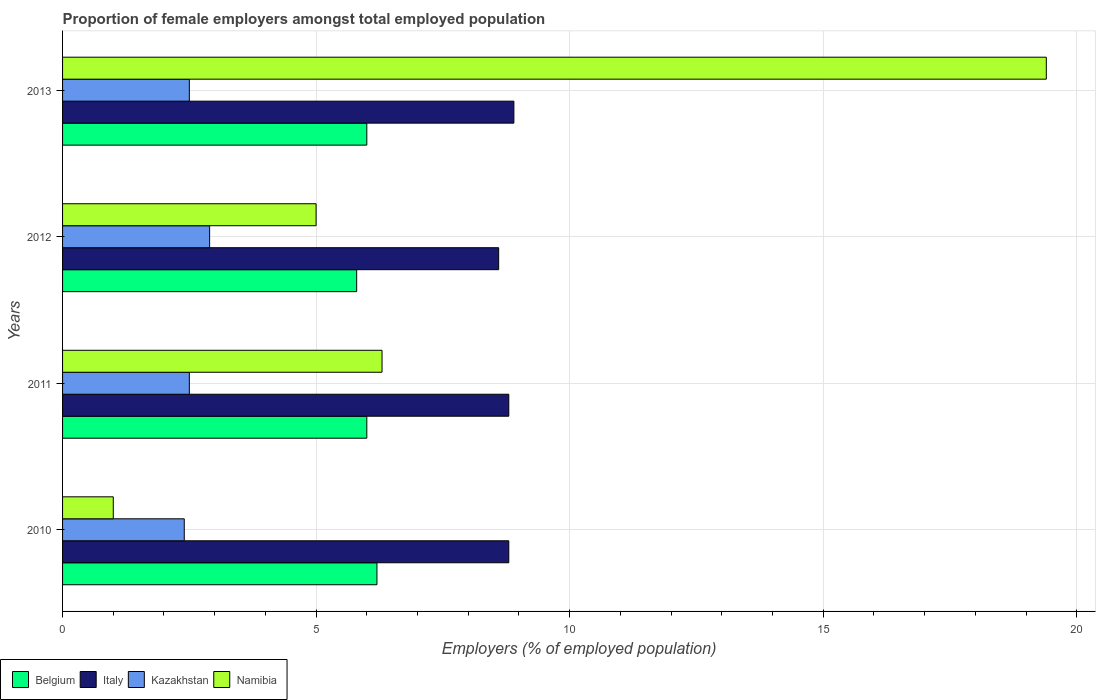Are the number of bars per tick equal to the number of legend labels?
Your response must be concise. Yes. Are the number of bars on each tick of the Y-axis equal?
Offer a terse response. Yes. How many bars are there on the 1st tick from the top?
Provide a short and direct response. 4. How many bars are there on the 2nd tick from the bottom?
Keep it short and to the point. 4. What is the label of the 2nd group of bars from the top?
Provide a succinct answer. 2012. In how many cases, is the number of bars for a given year not equal to the number of legend labels?
Your answer should be very brief. 0. What is the proportion of female employers in Kazakhstan in 2012?
Ensure brevity in your answer.  2.9. Across all years, what is the maximum proportion of female employers in Italy?
Keep it short and to the point. 8.9. Across all years, what is the minimum proportion of female employers in Italy?
Offer a terse response. 8.6. In which year was the proportion of female employers in Belgium maximum?
Offer a terse response. 2010. What is the total proportion of female employers in Kazakhstan in the graph?
Make the answer very short. 10.3. What is the difference between the proportion of female employers in Italy in 2011 and the proportion of female employers in Belgium in 2013?
Give a very brief answer. 2.8. In the year 2013, what is the difference between the proportion of female employers in Kazakhstan and proportion of female employers in Belgium?
Offer a very short reply. -3.5. In how many years, is the proportion of female employers in Kazakhstan greater than 19 %?
Your answer should be very brief. 0. What is the ratio of the proportion of female employers in Namibia in 2012 to that in 2013?
Provide a succinct answer. 0.26. What is the difference between the highest and the second highest proportion of female employers in Kazakhstan?
Give a very brief answer. 0.4. What is the difference between the highest and the lowest proportion of female employers in Namibia?
Make the answer very short. 18.4. In how many years, is the proportion of female employers in Italy greater than the average proportion of female employers in Italy taken over all years?
Keep it short and to the point. 3. Is it the case that in every year, the sum of the proportion of female employers in Belgium and proportion of female employers in Kazakhstan is greater than the sum of proportion of female employers in Italy and proportion of female employers in Namibia?
Ensure brevity in your answer.  No. What does the 4th bar from the bottom in 2012 represents?
Keep it short and to the point. Namibia. How many bars are there?
Offer a very short reply. 16. Are all the bars in the graph horizontal?
Provide a short and direct response. Yes. How many years are there in the graph?
Provide a succinct answer. 4. What is the difference between two consecutive major ticks on the X-axis?
Provide a succinct answer. 5. Are the values on the major ticks of X-axis written in scientific E-notation?
Offer a terse response. No. Does the graph contain any zero values?
Provide a short and direct response. No. Does the graph contain grids?
Make the answer very short. Yes. Where does the legend appear in the graph?
Provide a succinct answer. Bottom left. How are the legend labels stacked?
Your response must be concise. Horizontal. What is the title of the graph?
Make the answer very short. Proportion of female employers amongst total employed population. Does "Middle East & North Africa (developing only)" appear as one of the legend labels in the graph?
Provide a short and direct response. No. What is the label or title of the X-axis?
Provide a succinct answer. Employers (% of employed population). What is the label or title of the Y-axis?
Offer a terse response. Years. What is the Employers (% of employed population) in Belgium in 2010?
Your answer should be compact. 6.2. What is the Employers (% of employed population) of Italy in 2010?
Your response must be concise. 8.8. What is the Employers (% of employed population) in Kazakhstan in 2010?
Your answer should be compact. 2.4. What is the Employers (% of employed population) of Italy in 2011?
Ensure brevity in your answer.  8.8. What is the Employers (% of employed population) of Kazakhstan in 2011?
Offer a terse response. 2.5. What is the Employers (% of employed population) of Namibia in 2011?
Make the answer very short. 6.3. What is the Employers (% of employed population) of Belgium in 2012?
Offer a terse response. 5.8. What is the Employers (% of employed population) in Italy in 2012?
Offer a very short reply. 8.6. What is the Employers (% of employed population) in Kazakhstan in 2012?
Offer a terse response. 2.9. What is the Employers (% of employed population) of Belgium in 2013?
Your answer should be compact. 6. What is the Employers (% of employed population) of Italy in 2013?
Provide a short and direct response. 8.9. What is the Employers (% of employed population) in Namibia in 2013?
Offer a very short reply. 19.4. Across all years, what is the maximum Employers (% of employed population) in Belgium?
Make the answer very short. 6.2. Across all years, what is the maximum Employers (% of employed population) in Italy?
Your response must be concise. 8.9. Across all years, what is the maximum Employers (% of employed population) of Kazakhstan?
Your answer should be compact. 2.9. Across all years, what is the maximum Employers (% of employed population) in Namibia?
Provide a short and direct response. 19.4. Across all years, what is the minimum Employers (% of employed population) of Belgium?
Offer a terse response. 5.8. Across all years, what is the minimum Employers (% of employed population) in Italy?
Offer a terse response. 8.6. Across all years, what is the minimum Employers (% of employed population) of Kazakhstan?
Make the answer very short. 2.4. Across all years, what is the minimum Employers (% of employed population) of Namibia?
Provide a succinct answer. 1. What is the total Employers (% of employed population) of Italy in the graph?
Make the answer very short. 35.1. What is the total Employers (% of employed population) in Kazakhstan in the graph?
Make the answer very short. 10.3. What is the total Employers (% of employed population) of Namibia in the graph?
Your response must be concise. 31.7. What is the difference between the Employers (% of employed population) in Belgium in 2010 and that in 2011?
Provide a short and direct response. 0.2. What is the difference between the Employers (% of employed population) in Namibia in 2010 and that in 2011?
Make the answer very short. -5.3. What is the difference between the Employers (% of employed population) in Belgium in 2010 and that in 2012?
Ensure brevity in your answer.  0.4. What is the difference between the Employers (% of employed population) in Italy in 2010 and that in 2012?
Keep it short and to the point. 0.2. What is the difference between the Employers (% of employed population) of Kazakhstan in 2010 and that in 2012?
Make the answer very short. -0.5. What is the difference between the Employers (% of employed population) of Italy in 2010 and that in 2013?
Provide a short and direct response. -0.1. What is the difference between the Employers (% of employed population) of Kazakhstan in 2010 and that in 2013?
Offer a terse response. -0.1. What is the difference between the Employers (% of employed population) of Namibia in 2010 and that in 2013?
Provide a succinct answer. -18.4. What is the difference between the Employers (% of employed population) in Belgium in 2011 and that in 2012?
Your answer should be very brief. 0.2. What is the difference between the Employers (% of employed population) in Italy in 2011 and that in 2012?
Provide a succinct answer. 0.2. What is the difference between the Employers (% of employed population) in Kazakhstan in 2011 and that in 2012?
Give a very brief answer. -0.4. What is the difference between the Employers (% of employed population) in Namibia in 2011 and that in 2012?
Offer a very short reply. 1.3. What is the difference between the Employers (% of employed population) of Belgium in 2011 and that in 2013?
Provide a succinct answer. 0. What is the difference between the Employers (% of employed population) of Italy in 2011 and that in 2013?
Your answer should be compact. -0.1. What is the difference between the Employers (% of employed population) in Kazakhstan in 2011 and that in 2013?
Offer a very short reply. 0. What is the difference between the Employers (% of employed population) of Namibia in 2011 and that in 2013?
Offer a terse response. -13.1. What is the difference between the Employers (% of employed population) of Kazakhstan in 2012 and that in 2013?
Your answer should be very brief. 0.4. What is the difference between the Employers (% of employed population) of Namibia in 2012 and that in 2013?
Keep it short and to the point. -14.4. What is the difference between the Employers (% of employed population) of Belgium in 2010 and the Employers (% of employed population) of Italy in 2011?
Your response must be concise. -2.6. What is the difference between the Employers (% of employed population) in Italy in 2010 and the Employers (% of employed population) in Namibia in 2011?
Your answer should be very brief. 2.5. What is the difference between the Employers (% of employed population) of Kazakhstan in 2010 and the Employers (% of employed population) of Namibia in 2011?
Keep it short and to the point. -3.9. What is the difference between the Employers (% of employed population) in Belgium in 2010 and the Employers (% of employed population) in Italy in 2012?
Your answer should be very brief. -2.4. What is the difference between the Employers (% of employed population) of Italy in 2010 and the Employers (% of employed population) of Kazakhstan in 2012?
Your answer should be compact. 5.9. What is the difference between the Employers (% of employed population) of Italy in 2010 and the Employers (% of employed population) of Kazakhstan in 2013?
Offer a very short reply. 6.3. What is the difference between the Employers (% of employed population) in Italy in 2010 and the Employers (% of employed population) in Namibia in 2013?
Make the answer very short. -10.6. What is the difference between the Employers (% of employed population) in Italy in 2011 and the Employers (% of employed population) in Namibia in 2012?
Offer a terse response. 3.8. What is the difference between the Employers (% of employed population) in Belgium in 2011 and the Employers (% of employed population) in Namibia in 2013?
Your response must be concise. -13.4. What is the difference between the Employers (% of employed population) in Italy in 2011 and the Employers (% of employed population) in Kazakhstan in 2013?
Make the answer very short. 6.3. What is the difference between the Employers (% of employed population) of Kazakhstan in 2011 and the Employers (% of employed population) of Namibia in 2013?
Your answer should be compact. -16.9. What is the difference between the Employers (% of employed population) in Belgium in 2012 and the Employers (% of employed population) in Namibia in 2013?
Give a very brief answer. -13.6. What is the difference between the Employers (% of employed population) in Italy in 2012 and the Employers (% of employed population) in Kazakhstan in 2013?
Give a very brief answer. 6.1. What is the difference between the Employers (% of employed population) in Italy in 2012 and the Employers (% of employed population) in Namibia in 2013?
Offer a terse response. -10.8. What is the difference between the Employers (% of employed population) of Kazakhstan in 2012 and the Employers (% of employed population) of Namibia in 2013?
Your answer should be very brief. -16.5. What is the average Employers (% of employed population) of Belgium per year?
Provide a succinct answer. 6. What is the average Employers (% of employed population) in Italy per year?
Make the answer very short. 8.78. What is the average Employers (% of employed population) in Kazakhstan per year?
Provide a short and direct response. 2.58. What is the average Employers (% of employed population) of Namibia per year?
Give a very brief answer. 7.92. In the year 2010, what is the difference between the Employers (% of employed population) of Belgium and Employers (% of employed population) of Namibia?
Make the answer very short. 5.2. In the year 2010, what is the difference between the Employers (% of employed population) in Italy and Employers (% of employed population) in Kazakhstan?
Offer a very short reply. 6.4. In the year 2010, what is the difference between the Employers (% of employed population) in Italy and Employers (% of employed population) in Namibia?
Offer a terse response. 7.8. In the year 2010, what is the difference between the Employers (% of employed population) in Kazakhstan and Employers (% of employed population) in Namibia?
Provide a short and direct response. 1.4. In the year 2012, what is the difference between the Employers (% of employed population) of Belgium and Employers (% of employed population) of Italy?
Offer a very short reply. -2.8. In the year 2012, what is the difference between the Employers (% of employed population) of Belgium and Employers (% of employed population) of Kazakhstan?
Make the answer very short. 2.9. In the year 2013, what is the difference between the Employers (% of employed population) of Belgium and Employers (% of employed population) of Italy?
Offer a very short reply. -2.9. In the year 2013, what is the difference between the Employers (% of employed population) in Italy and Employers (% of employed population) in Kazakhstan?
Ensure brevity in your answer.  6.4. In the year 2013, what is the difference between the Employers (% of employed population) in Kazakhstan and Employers (% of employed population) in Namibia?
Give a very brief answer. -16.9. What is the ratio of the Employers (% of employed population) in Kazakhstan in 2010 to that in 2011?
Keep it short and to the point. 0.96. What is the ratio of the Employers (% of employed population) of Namibia in 2010 to that in 2011?
Offer a very short reply. 0.16. What is the ratio of the Employers (% of employed population) of Belgium in 2010 to that in 2012?
Your response must be concise. 1.07. What is the ratio of the Employers (% of employed population) of Italy in 2010 to that in 2012?
Give a very brief answer. 1.02. What is the ratio of the Employers (% of employed population) of Kazakhstan in 2010 to that in 2012?
Keep it short and to the point. 0.83. What is the ratio of the Employers (% of employed population) in Namibia in 2010 to that in 2012?
Make the answer very short. 0.2. What is the ratio of the Employers (% of employed population) in Belgium in 2010 to that in 2013?
Your response must be concise. 1.03. What is the ratio of the Employers (% of employed population) in Italy in 2010 to that in 2013?
Ensure brevity in your answer.  0.99. What is the ratio of the Employers (% of employed population) of Kazakhstan in 2010 to that in 2013?
Make the answer very short. 0.96. What is the ratio of the Employers (% of employed population) of Namibia in 2010 to that in 2013?
Offer a very short reply. 0.05. What is the ratio of the Employers (% of employed population) in Belgium in 2011 to that in 2012?
Your answer should be very brief. 1.03. What is the ratio of the Employers (% of employed population) in Italy in 2011 to that in 2012?
Your response must be concise. 1.02. What is the ratio of the Employers (% of employed population) of Kazakhstan in 2011 to that in 2012?
Offer a very short reply. 0.86. What is the ratio of the Employers (% of employed population) of Namibia in 2011 to that in 2012?
Your answer should be very brief. 1.26. What is the ratio of the Employers (% of employed population) in Belgium in 2011 to that in 2013?
Give a very brief answer. 1. What is the ratio of the Employers (% of employed population) of Namibia in 2011 to that in 2013?
Make the answer very short. 0.32. What is the ratio of the Employers (% of employed population) of Belgium in 2012 to that in 2013?
Offer a terse response. 0.97. What is the ratio of the Employers (% of employed population) of Italy in 2012 to that in 2013?
Your answer should be compact. 0.97. What is the ratio of the Employers (% of employed population) in Kazakhstan in 2012 to that in 2013?
Offer a very short reply. 1.16. What is the ratio of the Employers (% of employed population) in Namibia in 2012 to that in 2013?
Provide a succinct answer. 0.26. What is the difference between the highest and the second highest Employers (% of employed population) in Italy?
Offer a terse response. 0.1. What is the difference between the highest and the second highest Employers (% of employed population) of Namibia?
Offer a very short reply. 13.1. What is the difference between the highest and the lowest Employers (% of employed population) of Belgium?
Your answer should be compact. 0.4. What is the difference between the highest and the lowest Employers (% of employed population) of Italy?
Provide a short and direct response. 0.3. What is the difference between the highest and the lowest Employers (% of employed population) of Kazakhstan?
Provide a succinct answer. 0.5. 